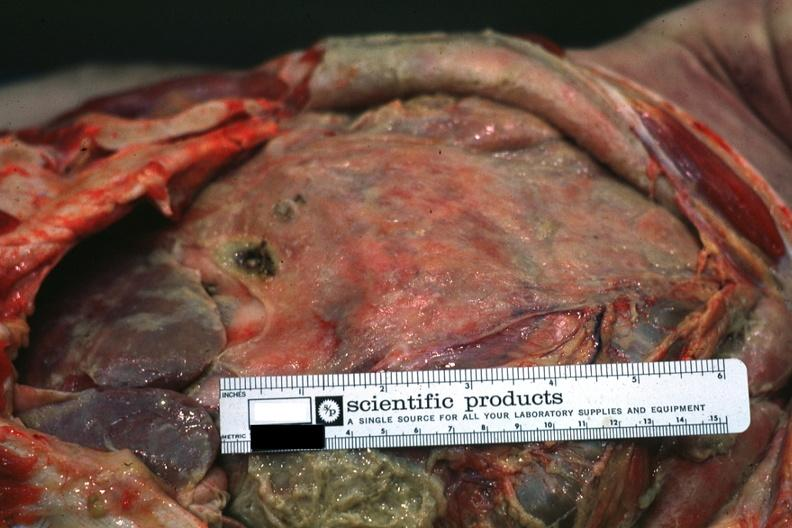does this image show intestines covered by fibrinopurulent membrane due to ruptured peptic ulcer?
Answer the question using a single word or phrase. Yes 